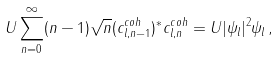Convert formula to latex. <formula><loc_0><loc_0><loc_500><loc_500>U \sum _ { n = 0 } ^ { \infty } ( n - 1 ) \sqrt { n } ( { c ^ { c o h } _ { { l } , n - 1 } } ) ^ { * } c ^ { c o h } _ { { l } , n } = U | \psi _ { l } | ^ { 2 } \psi _ { l } \, ,</formula> 